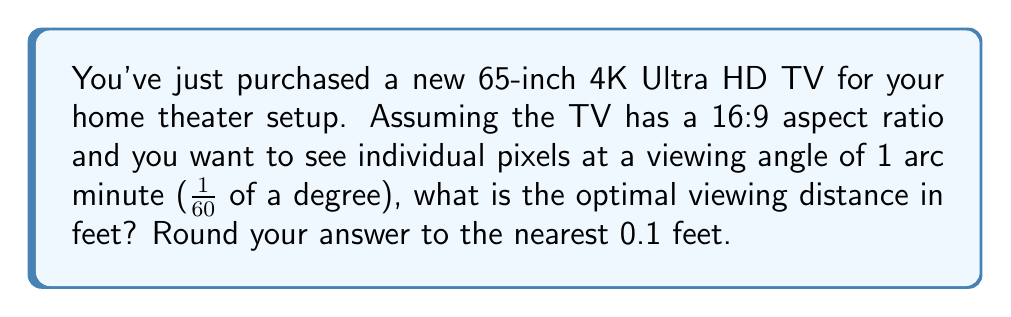Show me your answer to this math problem. Let's approach this step-by-step:

1) First, we need to calculate the width of the TV. For a 65-inch TV with a 16:9 aspect ratio:
   
   $$ \text{Width} = 65 \cdot \frac{16}{\sqrt{16^2 + 9^2}} \approx 56.7 \text{ inches} $$

2) A 4K TV has a horizontal resolution of 3840 pixels. The angle subtended by one pixel at the optimal distance is 1 arc minute (1/60 of a degree).

3) We can use the tangent function to relate the pixel size to the viewing distance:

   $$ \tan(\frac{1}{60} \cdot \frac{\pi}{180}) = \frac{\text{Pixel Width}}{\text{Viewing Distance}} $$

4) Pixel width can be calculated by dividing the TV width by the number of horizontal pixels:

   $$ \text{Pixel Width} = \frac{56.7}{3840} \approx 0.01477 \text{ inches} $$

5) Now we can solve for the viewing distance:

   $$ \text{Viewing Distance} = \frac{\text{Pixel Width}}{\tan(\frac{1}{60} \cdot \frac{\pi}{180})} $$

6) Plugging in the values:

   $$ \text{Viewing Distance} = \frac{0.01477}{\tan(\frac{1}{60} \cdot \frac{\pi}{180})} \approx 50.9 \text{ inches} $$

7) Converting to feet:

   $$ \text{Viewing Distance} \approx \frac{50.9}{12} \approx 4.2 \text{ feet} $$

Therefore, the optimal viewing distance is approximately 4.2 feet.
Answer: 4.2 feet 